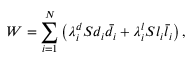<formula> <loc_0><loc_0><loc_500><loc_500>W = \sum _ { i = 1 } ^ { N } \left ( \lambda _ { i } ^ { d } S d _ { i } \bar { d } _ { i } + \lambda _ { i } ^ { l } S l _ { i } \bar { l } _ { i } \right ) ,</formula> 